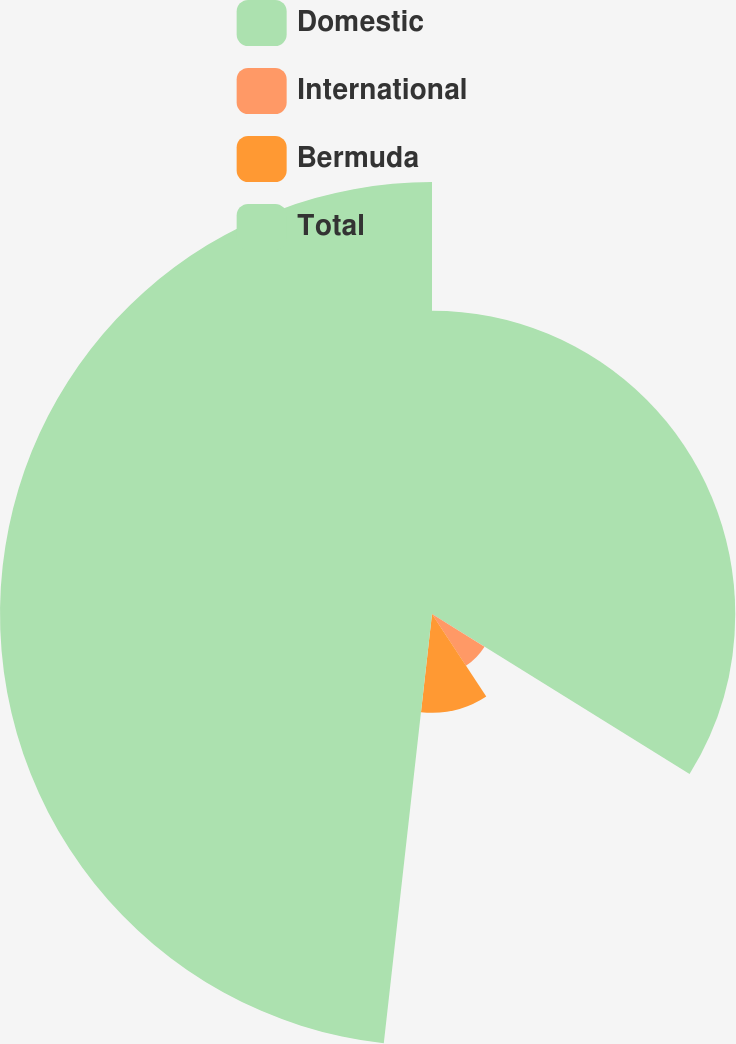<chart> <loc_0><loc_0><loc_500><loc_500><pie_chart><fcel>Domestic<fcel>International<fcel>Bermuda<fcel>Total<nl><fcel>33.85%<fcel>6.9%<fcel>11.03%<fcel>48.22%<nl></chart> 